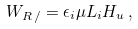Convert formula to latex. <formula><loc_0><loc_0><loc_500><loc_500>W _ { R \, \slash } = \epsilon _ { i } \mu L _ { i } H _ { u } \, ,</formula> 